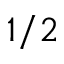<formula> <loc_0><loc_0><loc_500><loc_500>1 / 2</formula> 